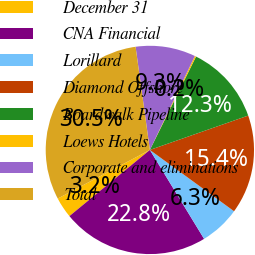Convert chart to OTSL. <chart><loc_0><loc_0><loc_500><loc_500><pie_chart><fcel>December 31<fcel>CNA Financial<fcel>Lorillard<fcel>Diamond Offshore<fcel>Boardwalk Pipeline<fcel>Loews Hotels<fcel>Corporate and eliminations<fcel>Total<nl><fcel>3.23%<fcel>22.76%<fcel>6.27%<fcel>15.37%<fcel>12.34%<fcel>0.2%<fcel>9.3%<fcel>30.54%<nl></chart> 